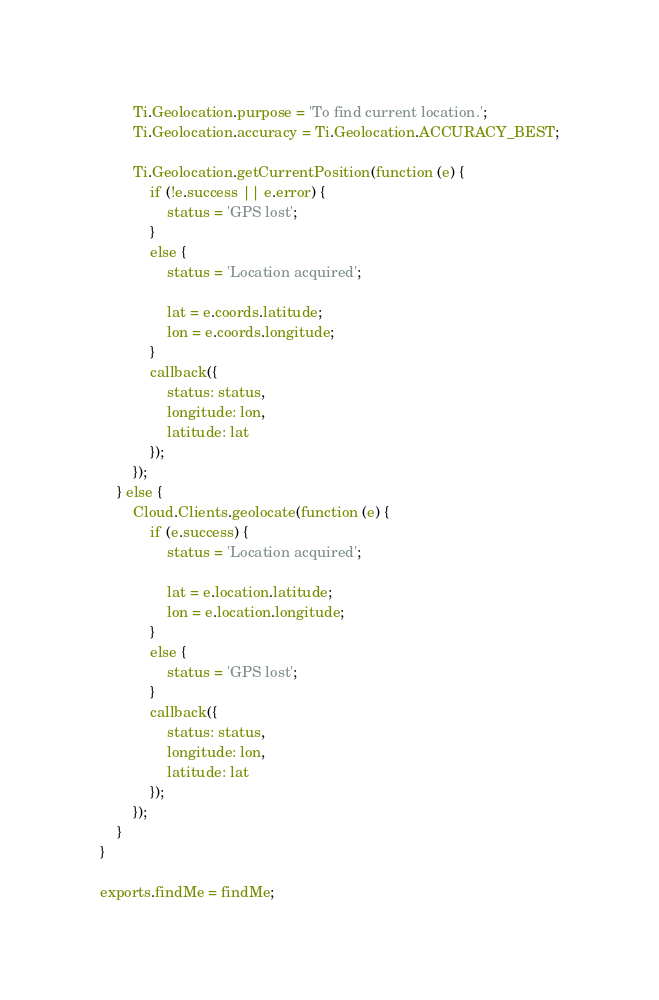Convert code to text. <code><loc_0><loc_0><loc_500><loc_500><_JavaScript_>		Ti.Geolocation.purpose = 'To find current location.';
		Ti.Geolocation.accuracy = Ti.Geolocation.ACCURACY_BEST;

		Ti.Geolocation.getCurrentPosition(function (e) {
			if (!e.success || e.error) {
				status = 'GPS lost';
			}
			else {
				status = 'Location acquired';

				lat = e.coords.latitude;
				lon = e.coords.longitude;
			}
			callback({
				status: status,
				longitude: lon,
				latitude: lat
			});
		});
	} else {
		Cloud.Clients.geolocate(function (e) {
			if (e.success) {
				status = 'Location acquired';

				lat = e.location.latitude;
				lon = e.location.longitude;
			}
			else {
				status = 'GPS lost';
			}
			callback({
				status: status,
				longitude: lon,
				latitude: lat
			});
		});
	}
}

exports.findMe = findMe;</code> 